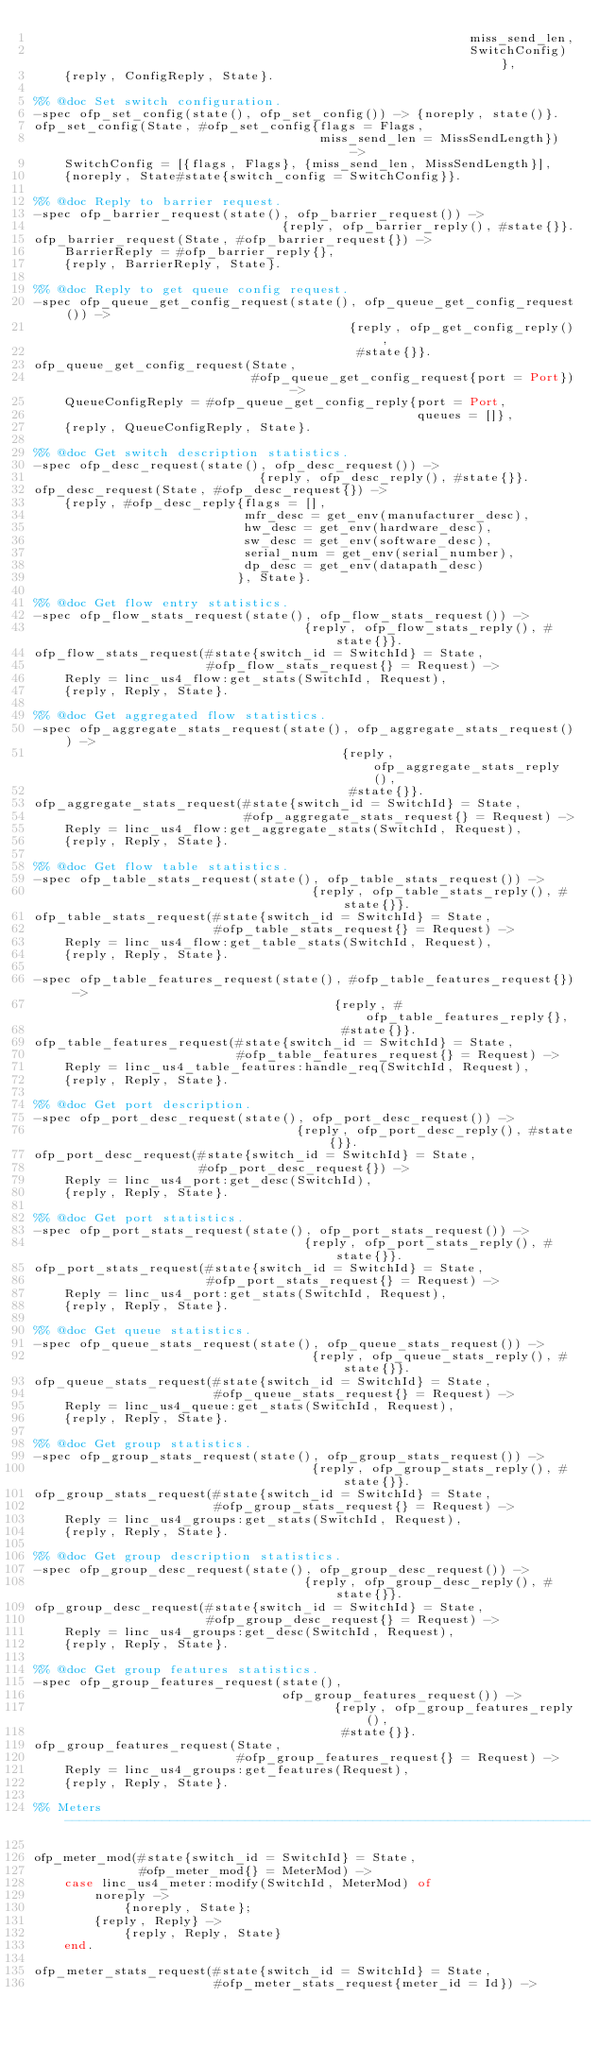<code> <loc_0><loc_0><loc_500><loc_500><_Erlang_>                                                          miss_send_len,
                                                          SwitchConfig)},
    {reply, ConfigReply, State}.

%% @doc Set switch configuration.
-spec ofp_set_config(state(), ofp_set_config()) -> {noreply, state()}.
ofp_set_config(State, #ofp_set_config{flags = Flags,
                                      miss_send_len = MissSendLength}) ->
    SwitchConfig = [{flags, Flags}, {miss_send_len, MissSendLength}],
    {noreply, State#state{switch_config = SwitchConfig}}.

%% @doc Reply to barrier request.
-spec ofp_barrier_request(state(), ofp_barrier_request()) ->
                                 {reply, ofp_barrier_reply(), #state{}}.
ofp_barrier_request(State, #ofp_barrier_request{}) ->
    BarrierReply = #ofp_barrier_reply{},
    {reply, BarrierReply, State}.

%% @doc Reply to get queue config request.
-spec ofp_queue_get_config_request(state(), ofp_queue_get_config_request()) ->
                                          {reply, ofp_get_config_reply(),
                                           #state{}}.
ofp_queue_get_config_request(State,
                             #ofp_queue_get_config_request{port = Port}) ->
    QueueConfigReply = #ofp_queue_get_config_reply{port = Port,
                                                   queues = []},
    {reply, QueueConfigReply, State}.

%% @doc Get switch description statistics.
-spec ofp_desc_request(state(), ofp_desc_request()) ->
                              {reply, ofp_desc_reply(), #state{}}.
ofp_desc_request(State, #ofp_desc_request{}) ->
    {reply, #ofp_desc_reply{flags = [],
                            mfr_desc = get_env(manufacturer_desc),
                            hw_desc = get_env(hardware_desc),
                            sw_desc = get_env(software_desc),
                            serial_num = get_env(serial_number),
                            dp_desc = get_env(datapath_desc)
                           }, State}.

%% @doc Get flow entry statistics.
-spec ofp_flow_stats_request(state(), ofp_flow_stats_request()) ->
                                    {reply, ofp_flow_stats_reply(), #state{}}.
ofp_flow_stats_request(#state{switch_id = SwitchId} = State,
                       #ofp_flow_stats_request{} = Request) ->
    Reply = linc_us4_flow:get_stats(SwitchId, Request),
    {reply, Reply, State}.

%% @doc Get aggregated flow statistics.
-spec ofp_aggregate_stats_request(state(), ofp_aggregate_stats_request()) ->
                                         {reply, ofp_aggregate_stats_reply(),
                                          #state{}}.
ofp_aggregate_stats_request(#state{switch_id = SwitchId} = State,
                            #ofp_aggregate_stats_request{} = Request) ->
    Reply = linc_us4_flow:get_aggregate_stats(SwitchId, Request),
    {reply, Reply, State}.

%% @doc Get flow table statistics.
-spec ofp_table_stats_request(state(), ofp_table_stats_request()) ->
                                     {reply, ofp_table_stats_reply(), #state{}}.
ofp_table_stats_request(#state{switch_id = SwitchId} = State,
                        #ofp_table_stats_request{} = Request) ->
    Reply = linc_us4_flow:get_table_stats(SwitchId, Request),
    {reply, Reply, State}.

-spec ofp_table_features_request(state(), #ofp_table_features_request{}) ->
                                        {reply, #ofp_table_features_reply{},
                                         #state{}}.
ofp_table_features_request(#state{switch_id = SwitchId} = State,
                           #ofp_table_features_request{} = Request) ->
    Reply = linc_us4_table_features:handle_req(SwitchId, Request),
    {reply, Reply, State}.

%% @doc Get port description.
-spec ofp_port_desc_request(state(), ofp_port_desc_request()) ->
                                   {reply, ofp_port_desc_reply(), #state{}}.
ofp_port_desc_request(#state{switch_id = SwitchId} = State,
                      #ofp_port_desc_request{}) ->
    Reply = linc_us4_port:get_desc(SwitchId),
    {reply, Reply, State}.

%% @doc Get port statistics.
-spec ofp_port_stats_request(state(), ofp_port_stats_request()) ->
                                    {reply, ofp_port_stats_reply(), #state{}}.
ofp_port_stats_request(#state{switch_id = SwitchId} = State,
                       #ofp_port_stats_request{} = Request) ->
    Reply = linc_us4_port:get_stats(SwitchId, Request),
    {reply, Reply, State}.

%% @doc Get queue statistics.
-spec ofp_queue_stats_request(state(), ofp_queue_stats_request()) ->
                                     {reply, ofp_queue_stats_reply(), #state{}}.
ofp_queue_stats_request(#state{switch_id = SwitchId} = State,
                        #ofp_queue_stats_request{} = Request) ->
    Reply = linc_us4_queue:get_stats(SwitchId, Request),
    {reply, Reply, State}.

%% @doc Get group statistics.
-spec ofp_group_stats_request(state(), ofp_group_stats_request()) ->
                                     {reply, ofp_group_stats_reply(), #state{}}.
ofp_group_stats_request(#state{switch_id = SwitchId} = State,
                        #ofp_group_stats_request{} = Request) ->
    Reply = linc_us4_groups:get_stats(SwitchId, Request),
    {reply, Reply, State}.

%% @doc Get group description statistics.
-spec ofp_group_desc_request(state(), ofp_group_desc_request()) ->
                                    {reply, ofp_group_desc_reply(), #state{}}.
ofp_group_desc_request(#state{switch_id = SwitchId} = State,
                       #ofp_group_desc_request{} = Request) ->
    Reply = linc_us4_groups:get_desc(SwitchId, Request),
    {reply, Reply, State}.

%% @doc Get group features statistics.
-spec ofp_group_features_request(state(),
                                 ofp_group_features_request()) ->
                                        {reply, ofp_group_features_reply(),
                                         #state{}}.
ofp_group_features_request(State,
                           #ofp_group_features_request{} = Request) ->
    Reply = linc_us4_groups:get_features(Request),
    {reply, Reply, State}.

%% Meters ----------------------------------------------------------------------

ofp_meter_mod(#state{switch_id = SwitchId} = State,
              #ofp_meter_mod{} = MeterMod) ->
    case linc_us4_meter:modify(SwitchId, MeterMod) of
        noreply ->
            {noreply, State};
        {reply, Reply} ->
            {reply, Reply, State}
    end.

ofp_meter_stats_request(#state{switch_id = SwitchId} = State,
                        #ofp_meter_stats_request{meter_id = Id}) -></code> 